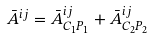<formula> <loc_0><loc_0><loc_500><loc_500>\bar { A } ^ { i j } = \bar { A } ^ { i j } _ { C _ { 1 } P _ { 1 } } + \bar { A } ^ { i j } _ { C _ { 2 } P _ { 2 } }</formula> 